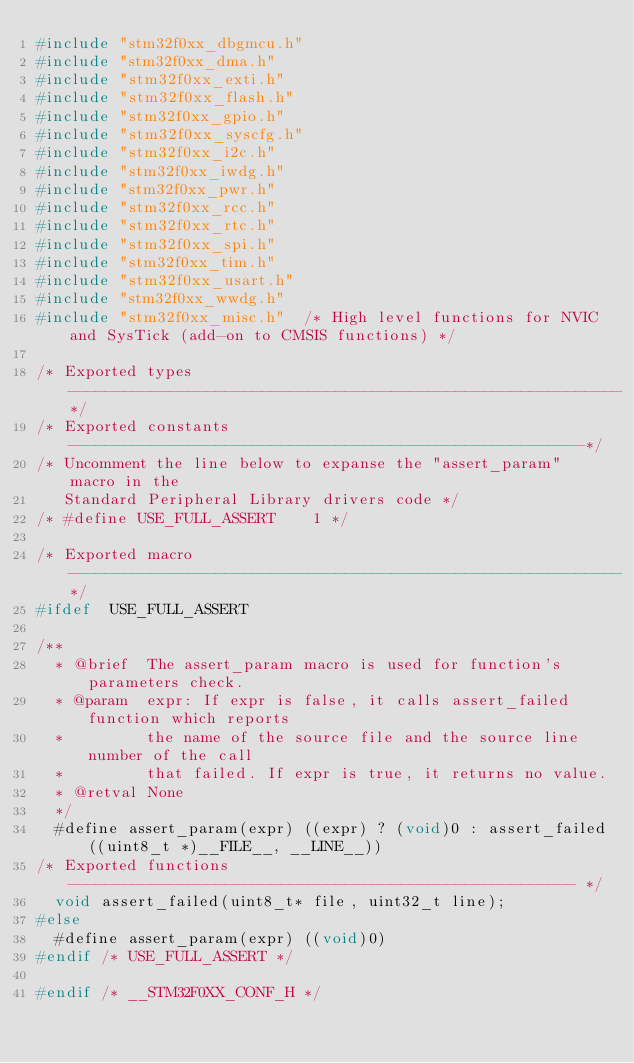Convert code to text. <code><loc_0><loc_0><loc_500><loc_500><_C_>#include "stm32f0xx_dbgmcu.h"
#include "stm32f0xx_dma.h"
#include "stm32f0xx_exti.h"
#include "stm32f0xx_flash.h"
#include "stm32f0xx_gpio.h"
#include "stm32f0xx_syscfg.h"
#include "stm32f0xx_i2c.h"
#include "stm32f0xx_iwdg.h"
#include "stm32f0xx_pwr.h"
#include "stm32f0xx_rcc.h"
#include "stm32f0xx_rtc.h"
#include "stm32f0xx_spi.h"
#include "stm32f0xx_tim.h"
#include "stm32f0xx_usart.h"
#include "stm32f0xx_wwdg.h"
#include "stm32f0xx_misc.h"  /* High level functions for NVIC and SysTick (add-on to CMSIS functions) */

/* Exported types ------------------------------------------------------------*/
/* Exported constants --------------------------------------------------------*/
/* Uncomment the line below to expanse the "assert_param" macro in the 
   Standard Peripheral Library drivers code */
/* #define USE_FULL_ASSERT    1 */

/* Exported macro ------------------------------------------------------------*/
#ifdef  USE_FULL_ASSERT

/**
  * @brief  The assert_param macro is used for function's parameters check.
  * @param  expr: If expr is false, it calls assert_failed function which reports 
  *         the name of the source file and the source line number of the call 
  *         that failed. If expr is true, it returns no value.
  * @retval None
  */
  #define assert_param(expr) ((expr) ? (void)0 : assert_failed((uint8_t *)__FILE__, __LINE__))
/* Exported functions ------------------------------------------------------- */
  void assert_failed(uint8_t* file, uint32_t line);
#else
  #define assert_param(expr) ((void)0)
#endif /* USE_FULL_ASSERT */

#endif /* __STM32F0XX_CONF_H */

</code> 